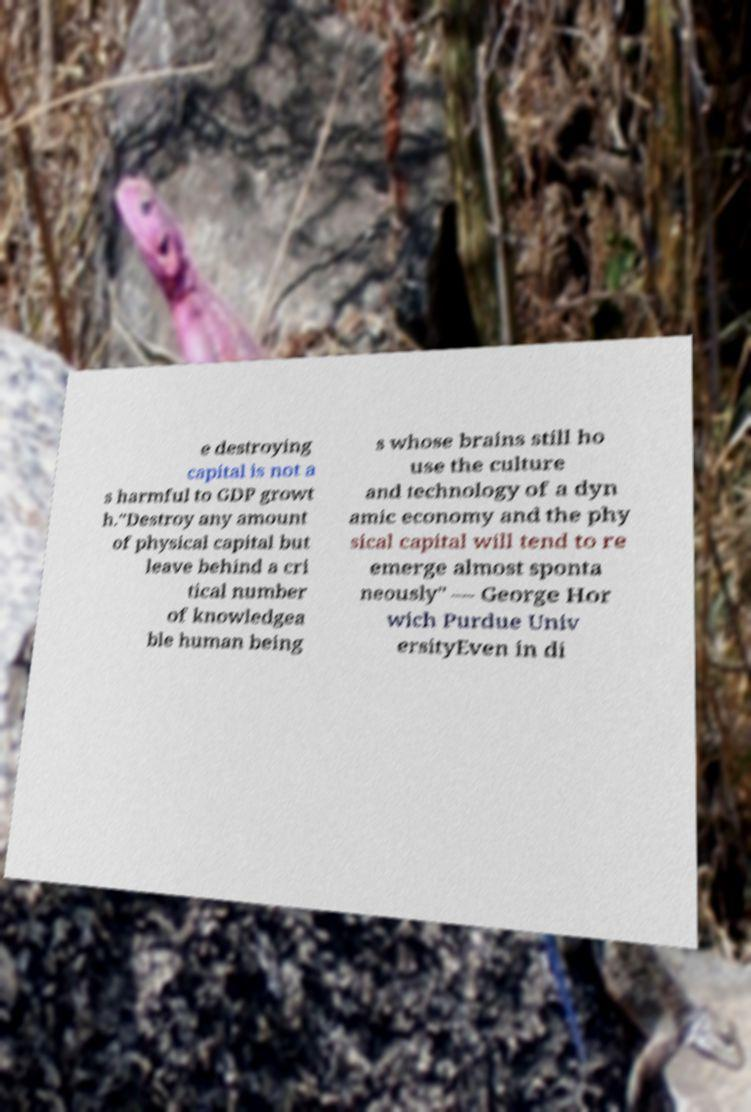Can you read and provide the text displayed in the image?This photo seems to have some interesting text. Can you extract and type it out for me? e destroying capital is not a s harmful to GDP growt h."Destroy any amount of physical capital but leave behind a cri tical number of knowledgea ble human being s whose brains still ho use the culture and technology of a dyn amic economy and the phy sical capital will tend to re emerge almost sponta neously" — George Hor wich Purdue Univ ersityEven in di 